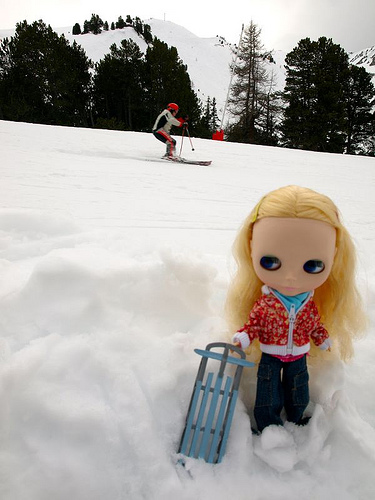<image>
Is there a doll next to the person? No. The doll is not positioned next to the person. They are located in different areas of the scene. Is the person above the doll? No. The person is not positioned above the doll. The vertical arrangement shows a different relationship. 